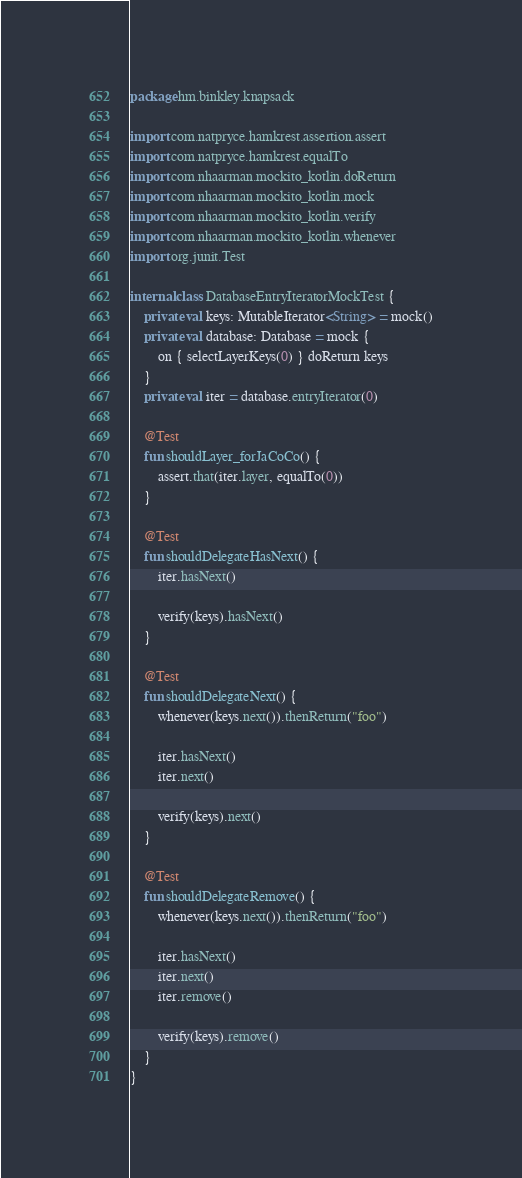<code> <loc_0><loc_0><loc_500><loc_500><_Kotlin_>package hm.binkley.knapsack

import com.natpryce.hamkrest.assertion.assert
import com.natpryce.hamkrest.equalTo
import com.nhaarman.mockito_kotlin.doReturn
import com.nhaarman.mockito_kotlin.mock
import com.nhaarman.mockito_kotlin.verify
import com.nhaarman.mockito_kotlin.whenever
import org.junit.Test

internal class DatabaseEntryIteratorMockTest {
    private val keys: MutableIterator<String> = mock()
    private val database: Database = mock {
        on { selectLayerKeys(0) } doReturn keys
    }
    private val iter = database.entryIterator(0)

    @Test
    fun shouldLayer_forJaCoCo() {
        assert.that(iter.layer, equalTo(0))
    }

    @Test
    fun shouldDelegateHasNext() {
        iter.hasNext()

        verify(keys).hasNext()
    }

    @Test
    fun shouldDelegateNext() {
        whenever(keys.next()).thenReturn("foo")

        iter.hasNext()
        iter.next()

        verify(keys).next()
    }

    @Test
    fun shouldDelegateRemove() {
        whenever(keys.next()).thenReturn("foo")

        iter.hasNext()
        iter.next()
        iter.remove()

        verify(keys).remove()
    }
}
</code> 